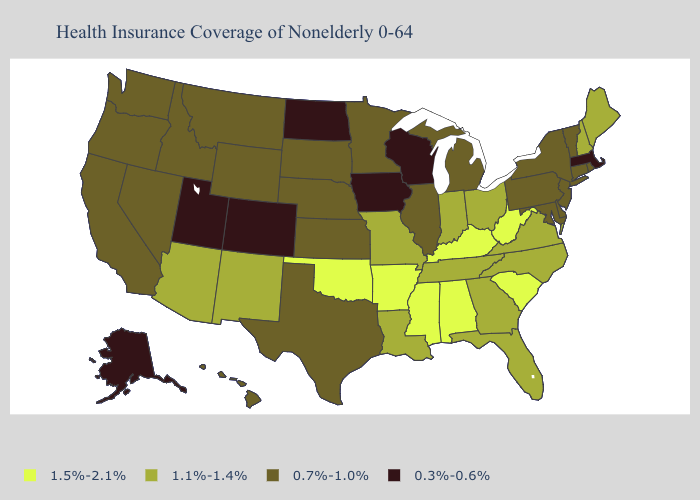Name the states that have a value in the range 1.1%-1.4%?
Short answer required. Arizona, Florida, Georgia, Indiana, Louisiana, Maine, Missouri, New Hampshire, New Mexico, North Carolina, Ohio, Tennessee, Virginia. Among the states that border Kansas , does Colorado have the highest value?
Answer briefly. No. What is the value of Florida?
Concise answer only. 1.1%-1.4%. Name the states that have a value in the range 0.7%-1.0%?
Short answer required. California, Connecticut, Delaware, Hawaii, Idaho, Illinois, Kansas, Maryland, Michigan, Minnesota, Montana, Nebraska, Nevada, New Jersey, New York, Oregon, Pennsylvania, Rhode Island, South Dakota, Texas, Vermont, Washington, Wyoming. What is the value of Ohio?
Keep it brief. 1.1%-1.4%. What is the value of New Mexico?
Short answer required. 1.1%-1.4%. What is the value of Wyoming?
Concise answer only. 0.7%-1.0%. Does Mississippi have a higher value than Missouri?
Give a very brief answer. Yes. What is the lowest value in the USA?
Short answer required. 0.3%-0.6%. Name the states that have a value in the range 0.7%-1.0%?
Give a very brief answer. California, Connecticut, Delaware, Hawaii, Idaho, Illinois, Kansas, Maryland, Michigan, Minnesota, Montana, Nebraska, Nevada, New Jersey, New York, Oregon, Pennsylvania, Rhode Island, South Dakota, Texas, Vermont, Washington, Wyoming. Does Vermont have a higher value than Kentucky?
Be succinct. No. Does North Dakota have the lowest value in the MidWest?
Be succinct. Yes. Name the states that have a value in the range 1.1%-1.4%?
Be succinct. Arizona, Florida, Georgia, Indiana, Louisiana, Maine, Missouri, New Hampshire, New Mexico, North Carolina, Ohio, Tennessee, Virginia. What is the value of Ohio?
Answer briefly. 1.1%-1.4%. Which states have the highest value in the USA?
Be succinct. Alabama, Arkansas, Kentucky, Mississippi, Oklahoma, South Carolina, West Virginia. 